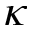Convert formula to latex. <formula><loc_0><loc_0><loc_500><loc_500>\kappa</formula> 